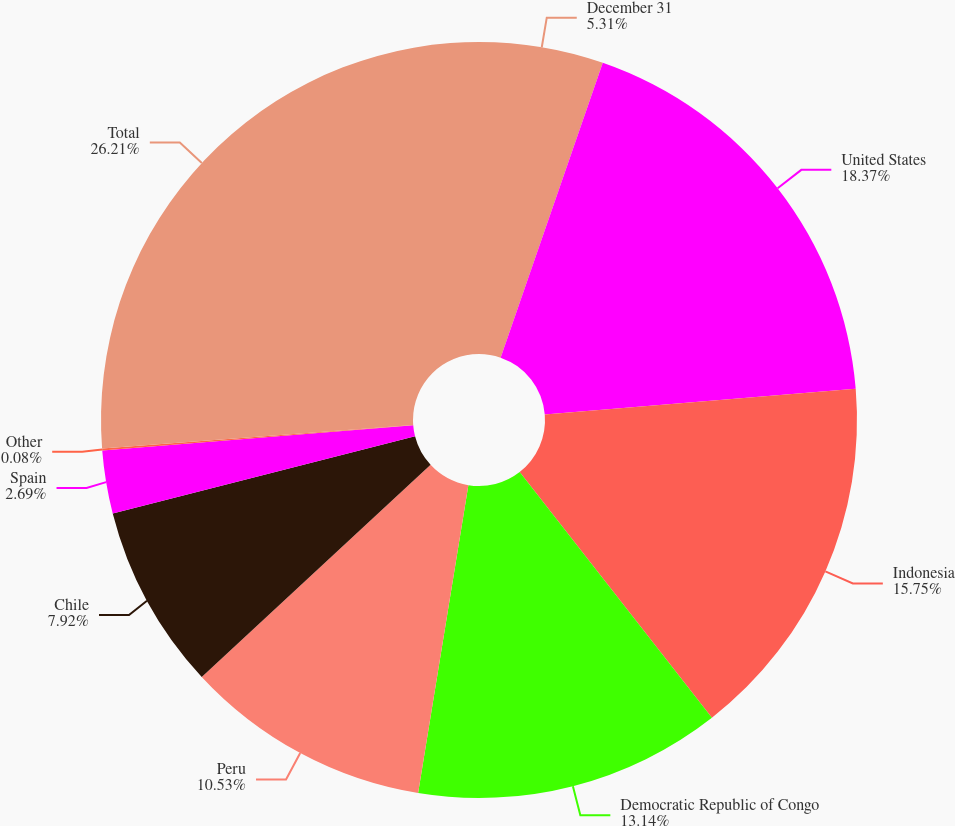<chart> <loc_0><loc_0><loc_500><loc_500><pie_chart><fcel>December 31<fcel>United States<fcel>Indonesia<fcel>Democratic Republic of Congo<fcel>Peru<fcel>Chile<fcel>Spain<fcel>Other<fcel>Total<nl><fcel>5.31%<fcel>18.37%<fcel>15.75%<fcel>13.14%<fcel>10.53%<fcel>7.92%<fcel>2.69%<fcel>0.08%<fcel>26.2%<nl></chart> 